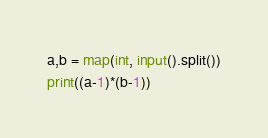<code> <loc_0><loc_0><loc_500><loc_500><_Python_>a,b = map(int, input().split())
print((a-1)*(b-1))</code> 